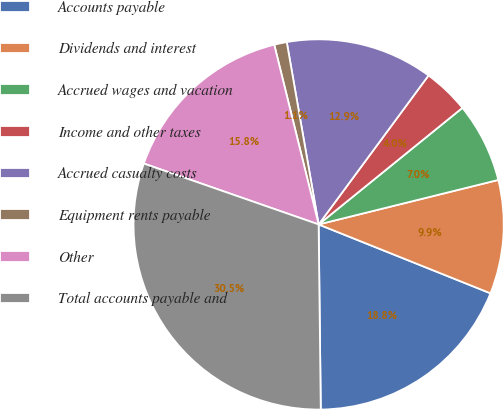Convert chart. <chart><loc_0><loc_0><loc_500><loc_500><pie_chart><fcel>Accounts payable<fcel>Dividends and interest<fcel>Accrued wages and vacation<fcel>Income and other taxes<fcel>Accrued casualty costs<fcel>Equipment rents payable<fcel>Other<fcel>Total accounts payable and<nl><fcel>18.75%<fcel>9.93%<fcel>6.98%<fcel>4.04%<fcel>12.87%<fcel>1.1%<fcel>15.81%<fcel>30.52%<nl></chart> 